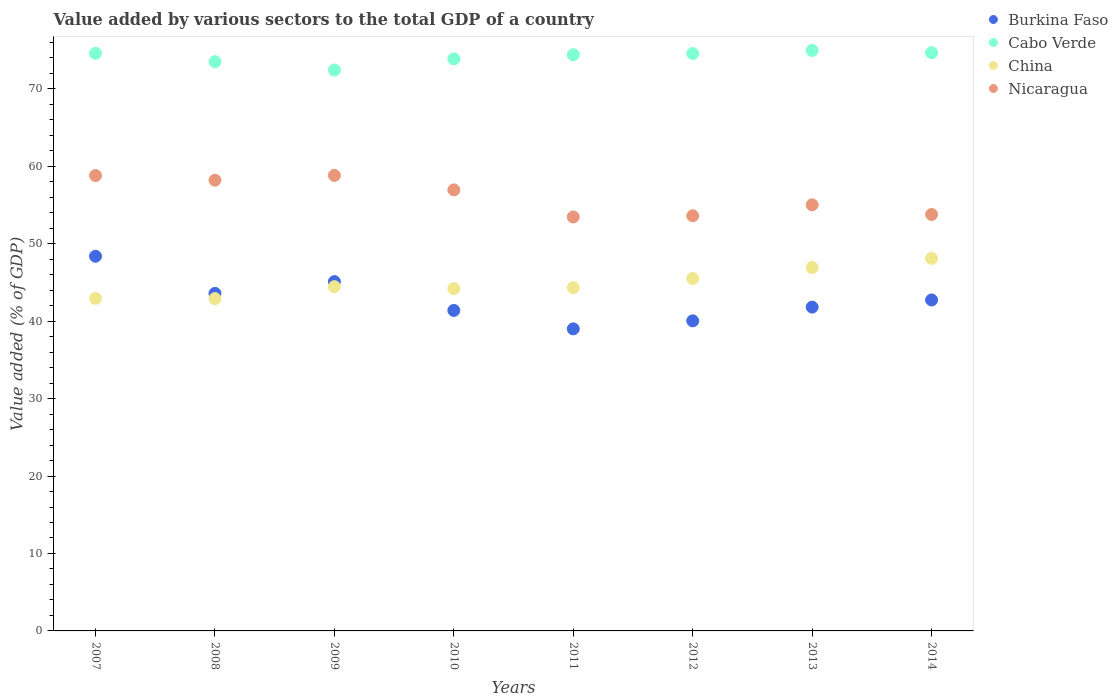What is the value added by various sectors to the total GDP in Cabo Verde in 2012?
Your answer should be very brief. 74.55. Across all years, what is the maximum value added by various sectors to the total GDP in Burkina Faso?
Offer a very short reply. 48.38. Across all years, what is the minimum value added by various sectors to the total GDP in Cabo Verde?
Ensure brevity in your answer.  72.42. In which year was the value added by various sectors to the total GDP in Burkina Faso minimum?
Provide a short and direct response. 2011. What is the total value added by various sectors to the total GDP in Burkina Faso in the graph?
Keep it short and to the point. 342.02. What is the difference between the value added by various sectors to the total GDP in Burkina Faso in 2012 and that in 2014?
Provide a succinct answer. -2.7. What is the difference between the value added by various sectors to the total GDP in Burkina Faso in 2011 and the value added by various sectors to the total GDP in China in 2013?
Offer a very short reply. -7.92. What is the average value added by various sectors to the total GDP in Burkina Faso per year?
Provide a succinct answer. 42.75. In the year 2014, what is the difference between the value added by various sectors to the total GDP in Cabo Verde and value added by various sectors to the total GDP in China?
Ensure brevity in your answer.  26.55. In how many years, is the value added by various sectors to the total GDP in Burkina Faso greater than 64 %?
Your response must be concise. 0. What is the ratio of the value added by various sectors to the total GDP in Cabo Verde in 2009 to that in 2011?
Ensure brevity in your answer.  0.97. Is the value added by various sectors to the total GDP in China in 2008 less than that in 2010?
Provide a short and direct response. Yes. Is the difference between the value added by various sectors to the total GDP in Cabo Verde in 2010 and 2011 greater than the difference between the value added by various sectors to the total GDP in China in 2010 and 2011?
Keep it short and to the point. No. What is the difference between the highest and the second highest value added by various sectors to the total GDP in Nicaragua?
Keep it short and to the point. 0.02. What is the difference between the highest and the lowest value added by various sectors to the total GDP in Nicaragua?
Offer a terse response. 5.37. In how many years, is the value added by various sectors to the total GDP in China greater than the average value added by various sectors to the total GDP in China taken over all years?
Make the answer very short. 3. Is it the case that in every year, the sum of the value added by various sectors to the total GDP in Nicaragua and value added by various sectors to the total GDP in Burkina Faso  is greater than the value added by various sectors to the total GDP in China?
Your response must be concise. Yes. Does the value added by various sectors to the total GDP in China monotonically increase over the years?
Give a very brief answer. No. Is the value added by various sectors to the total GDP in Burkina Faso strictly less than the value added by various sectors to the total GDP in China over the years?
Provide a succinct answer. No. How many dotlines are there?
Your response must be concise. 4. How many years are there in the graph?
Keep it short and to the point. 8. What is the difference between two consecutive major ticks on the Y-axis?
Provide a succinct answer. 10. Does the graph contain any zero values?
Your answer should be compact. No. Where does the legend appear in the graph?
Your answer should be very brief. Top right. How many legend labels are there?
Ensure brevity in your answer.  4. What is the title of the graph?
Give a very brief answer. Value added by various sectors to the total GDP of a country. What is the label or title of the Y-axis?
Give a very brief answer. Value added (% of GDP). What is the Value added (% of GDP) of Burkina Faso in 2007?
Keep it short and to the point. 48.38. What is the Value added (% of GDP) of Cabo Verde in 2007?
Your answer should be very brief. 74.58. What is the Value added (% of GDP) in China in 2007?
Make the answer very short. 42.94. What is the Value added (% of GDP) of Nicaragua in 2007?
Make the answer very short. 58.79. What is the Value added (% of GDP) of Burkina Faso in 2008?
Keep it short and to the point. 43.58. What is the Value added (% of GDP) in Cabo Verde in 2008?
Offer a terse response. 73.49. What is the Value added (% of GDP) of China in 2008?
Make the answer very short. 42.91. What is the Value added (% of GDP) in Nicaragua in 2008?
Provide a succinct answer. 58.2. What is the Value added (% of GDP) in Burkina Faso in 2009?
Ensure brevity in your answer.  45.1. What is the Value added (% of GDP) in Cabo Verde in 2009?
Make the answer very short. 72.42. What is the Value added (% of GDP) of China in 2009?
Ensure brevity in your answer.  44.45. What is the Value added (% of GDP) of Nicaragua in 2009?
Make the answer very short. 58.82. What is the Value added (% of GDP) in Burkina Faso in 2010?
Ensure brevity in your answer.  41.38. What is the Value added (% of GDP) in Cabo Verde in 2010?
Provide a succinct answer. 73.86. What is the Value added (% of GDP) of China in 2010?
Provide a short and direct response. 44.2. What is the Value added (% of GDP) in Nicaragua in 2010?
Make the answer very short. 56.95. What is the Value added (% of GDP) of Burkina Faso in 2011?
Provide a short and direct response. 39. What is the Value added (% of GDP) in Cabo Verde in 2011?
Provide a succinct answer. 74.39. What is the Value added (% of GDP) of China in 2011?
Keep it short and to the point. 44.32. What is the Value added (% of GDP) of Nicaragua in 2011?
Keep it short and to the point. 53.45. What is the Value added (% of GDP) of Burkina Faso in 2012?
Provide a short and direct response. 40.03. What is the Value added (% of GDP) in Cabo Verde in 2012?
Give a very brief answer. 74.55. What is the Value added (% of GDP) of China in 2012?
Keep it short and to the point. 45.5. What is the Value added (% of GDP) in Nicaragua in 2012?
Give a very brief answer. 53.6. What is the Value added (% of GDP) of Burkina Faso in 2013?
Ensure brevity in your answer.  41.81. What is the Value added (% of GDP) in Cabo Verde in 2013?
Provide a short and direct response. 74.94. What is the Value added (% of GDP) in China in 2013?
Keep it short and to the point. 46.92. What is the Value added (% of GDP) of Nicaragua in 2013?
Give a very brief answer. 55.01. What is the Value added (% of GDP) in Burkina Faso in 2014?
Ensure brevity in your answer.  42.74. What is the Value added (% of GDP) of Cabo Verde in 2014?
Your answer should be very brief. 74.66. What is the Value added (% of GDP) in China in 2014?
Your answer should be compact. 48.11. What is the Value added (% of GDP) in Nicaragua in 2014?
Offer a terse response. 53.77. Across all years, what is the maximum Value added (% of GDP) of Burkina Faso?
Your answer should be compact. 48.38. Across all years, what is the maximum Value added (% of GDP) of Cabo Verde?
Provide a succinct answer. 74.94. Across all years, what is the maximum Value added (% of GDP) in China?
Offer a terse response. 48.11. Across all years, what is the maximum Value added (% of GDP) in Nicaragua?
Give a very brief answer. 58.82. Across all years, what is the minimum Value added (% of GDP) of Burkina Faso?
Give a very brief answer. 39. Across all years, what is the minimum Value added (% of GDP) in Cabo Verde?
Your answer should be compact. 72.42. Across all years, what is the minimum Value added (% of GDP) of China?
Provide a short and direct response. 42.91. Across all years, what is the minimum Value added (% of GDP) of Nicaragua?
Your answer should be compact. 53.45. What is the total Value added (% of GDP) in Burkina Faso in the graph?
Offer a very short reply. 342.02. What is the total Value added (% of GDP) of Cabo Verde in the graph?
Your answer should be very brief. 592.89. What is the total Value added (% of GDP) of China in the graph?
Your answer should be compact. 359.35. What is the total Value added (% of GDP) of Nicaragua in the graph?
Your response must be concise. 448.59. What is the difference between the Value added (% of GDP) of Burkina Faso in 2007 and that in 2008?
Offer a very short reply. 4.8. What is the difference between the Value added (% of GDP) of Cabo Verde in 2007 and that in 2008?
Provide a short and direct response. 1.09. What is the difference between the Value added (% of GDP) of China in 2007 and that in 2008?
Make the answer very short. 0.03. What is the difference between the Value added (% of GDP) of Nicaragua in 2007 and that in 2008?
Offer a terse response. 0.6. What is the difference between the Value added (% of GDP) of Burkina Faso in 2007 and that in 2009?
Your answer should be very brief. 3.27. What is the difference between the Value added (% of GDP) of Cabo Verde in 2007 and that in 2009?
Your answer should be very brief. 2.16. What is the difference between the Value added (% of GDP) of China in 2007 and that in 2009?
Your answer should be very brief. -1.51. What is the difference between the Value added (% of GDP) in Nicaragua in 2007 and that in 2009?
Your answer should be compact. -0.02. What is the difference between the Value added (% of GDP) in Burkina Faso in 2007 and that in 2010?
Your answer should be very brief. 7. What is the difference between the Value added (% of GDP) of Cabo Verde in 2007 and that in 2010?
Keep it short and to the point. 0.72. What is the difference between the Value added (% of GDP) in China in 2007 and that in 2010?
Offer a terse response. -1.26. What is the difference between the Value added (% of GDP) in Nicaragua in 2007 and that in 2010?
Keep it short and to the point. 1.84. What is the difference between the Value added (% of GDP) of Burkina Faso in 2007 and that in 2011?
Ensure brevity in your answer.  9.37. What is the difference between the Value added (% of GDP) in Cabo Verde in 2007 and that in 2011?
Give a very brief answer. 0.19. What is the difference between the Value added (% of GDP) in China in 2007 and that in 2011?
Make the answer very short. -1.38. What is the difference between the Value added (% of GDP) of Nicaragua in 2007 and that in 2011?
Make the answer very short. 5.34. What is the difference between the Value added (% of GDP) of Burkina Faso in 2007 and that in 2012?
Ensure brevity in your answer.  8.34. What is the difference between the Value added (% of GDP) of Cabo Verde in 2007 and that in 2012?
Ensure brevity in your answer.  0.03. What is the difference between the Value added (% of GDP) of China in 2007 and that in 2012?
Provide a short and direct response. -2.56. What is the difference between the Value added (% of GDP) in Nicaragua in 2007 and that in 2012?
Provide a short and direct response. 5.19. What is the difference between the Value added (% of GDP) of Burkina Faso in 2007 and that in 2013?
Offer a terse response. 6.57. What is the difference between the Value added (% of GDP) of Cabo Verde in 2007 and that in 2013?
Ensure brevity in your answer.  -0.36. What is the difference between the Value added (% of GDP) in China in 2007 and that in 2013?
Give a very brief answer. -3.98. What is the difference between the Value added (% of GDP) of Nicaragua in 2007 and that in 2013?
Ensure brevity in your answer.  3.78. What is the difference between the Value added (% of GDP) of Burkina Faso in 2007 and that in 2014?
Give a very brief answer. 5.64. What is the difference between the Value added (% of GDP) of Cabo Verde in 2007 and that in 2014?
Keep it short and to the point. -0.08. What is the difference between the Value added (% of GDP) of China in 2007 and that in 2014?
Your answer should be compact. -5.17. What is the difference between the Value added (% of GDP) of Nicaragua in 2007 and that in 2014?
Offer a terse response. 5.02. What is the difference between the Value added (% of GDP) of Burkina Faso in 2008 and that in 2009?
Your answer should be compact. -1.52. What is the difference between the Value added (% of GDP) in Cabo Verde in 2008 and that in 2009?
Your answer should be compact. 1.07. What is the difference between the Value added (% of GDP) of China in 2008 and that in 2009?
Provide a succinct answer. -1.54. What is the difference between the Value added (% of GDP) in Nicaragua in 2008 and that in 2009?
Keep it short and to the point. -0.62. What is the difference between the Value added (% of GDP) in Burkina Faso in 2008 and that in 2010?
Keep it short and to the point. 2.2. What is the difference between the Value added (% of GDP) in Cabo Verde in 2008 and that in 2010?
Your response must be concise. -0.37. What is the difference between the Value added (% of GDP) in China in 2008 and that in 2010?
Ensure brevity in your answer.  -1.3. What is the difference between the Value added (% of GDP) in Nicaragua in 2008 and that in 2010?
Provide a short and direct response. 1.25. What is the difference between the Value added (% of GDP) of Burkina Faso in 2008 and that in 2011?
Offer a very short reply. 4.58. What is the difference between the Value added (% of GDP) of Cabo Verde in 2008 and that in 2011?
Give a very brief answer. -0.9. What is the difference between the Value added (% of GDP) in China in 2008 and that in 2011?
Your answer should be very brief. -1.42. What is the difference between the Value added (% of GDP) of Nicaragua in 2008 and that in 2011?
Offer a very short reply. 4.75. What is the difference between the Value added (% of GDP) of Burkina Faso in 2008 and that in 2012?
Ensure brevity in your answer.  3.54. What is the difference between the Value added (% of GDP) in Cabo Verde in 2008 and that in 2012?
Ensure brevity in your answer.  -1.06. What is the difference between the Value added (% of GDP) in China in 2008 and that in 2012?
Make the answer very short. -2.59. What is the difference between the Value added (% of GDP) of Nicaragua in 2008 and that in 2012?
Your response must be concise. 4.59. What is the difference between the Value added (% of GDP) in Burkina Faso in 2008 and that in 2013?
Your answer should be very brief. 1.77. What is the difference between the Value added (% of GDP) in Cabo Verde in 2008 and that in 2013?
Make the answer very short. -1.45. What is the difference between the Value added (% of GDP) in China in 2008 and that in 2013?
Your response must be concise. -4.01. What is the difference between the Value added (% of GDP) in Nicaragua in 2008 and that in 2013?
Offer a terse response. 3.19. What is the difference between the Value added (% of GDP) in Burkina Faso in 2008 and that in 2014?
Your answer should be very brief. 0.84. What is the difference between the Value added (% of GDP) of Cabo Verde in 2008 and that in 2014?
Provide a short and direct response. -1.17. What is the difference between the Value added (% of GDP) in China in 2008 and that in 2014?
Make the answer very short. -5.2. What is the difference between the Value added (% of GDP) of Nicaragua in 2008 and that in 2014?
Ensure brevity in your answer.  4.42. What is the difference between the Value added (% of GDP) in Burkina Faso in 2009 and that in 2010?
Offer a terse response. 3.72. What is the difference between the Value added (% of GDP) of Cabo Verde in 2009 and that in 2010?
Ensure brevity in your answer.  -1.44. What is the difference between the Value added (% of GDP) of China in 2009 and that in 2010?
Give a very brief answer. 0.25. What is the difference between the Value added (% of GDP) in Nicaragua in 2009 and that in 2010?
Keep it short and to the point. 1.87. What is the difference between the Value added (% of GDP) in Burkina Faso in 2009 and that in 2011?
Offer a very short reply. 6.1. What is the difference between the Value added (% of GDP) of Cabo Verde in 2009 and that in 2011?
Ensure brevity in your answer.  -1.97. What is the difference between the Value added (% of GDP) in China in 2009 and that in 2011?
Offer a terse response. 0.12. What is the difference between the Value added (% of GDP) in Nicaragua in 2009 and that in 2011?
Keep it short and to the point. 5.37. What is the difference between the Value added (% of GDP) in Burkina Faso in 2009 and that in 2012?
Give a very brief answer. 5.07. What is the difference between the Value added (% of GDP) in Cabo Verde in 2009 and that in 2012?
Your answer should be compact. -2.13. What is the difference between the Value added (% of GDP) in China in 2009 and that in 2012?
Ensure brevity in your answer.  -1.05. What is the difference between the Value added (% of GDP) of Nicaragua in 2009 and that in 2012?
Provide a succinct answer. 5.21. What is the difference between the Value added (% of GDP) of Burkina Faso in 2009 and that in 2013?
Ensure brevity in your answer.  3.29. What is the difference between the Value added (% of GDP) in Cabo Verde in 2009 and that in 2013?
Give a very brief answer. -2.52. What is the difference between the Value added (% of GDP) of China in 2009 and that in 2013?
Make the answer very short. -2.47. What is the difference between the Value added (% of GDP) in Nicaragua in 2009 and that in 2013?
Your answer should be very brief. 3.8. What is the difference between the Value added (% of GDP) of Burkina Faso in 2009 and that in 2014?
Your answer should be very brief. 2.37. What is the difference between the Value added (% of GDP) of Cabo Verde in 2009 and that in 2014?
Your answer should be very brief. -2.24. What is the difference between the Value added (% of GDP) of China in 2009 and that in 2014?
Your answer should be compact. -3.66. What is the difference between the Value added (% of GDP) in Nicaragua in 2009 and that in 2014?
Offer a terse response. 5.04. What is the difference between the Value added (% of GDP) in Burkina Faso in 2010 and that in 2011?
Provide a succinct answer. 2.38. What is the difference between the Value added (% of GDP) of Cabo Verde in 2010 and that in 2011?
Ensure brevity in your answer.  -0.53. What is the difference between the Value added (% of GDP) in China in 2010 and that in 2011?
Your answer should be very brief. -0.12. What is the difference between the Value added (% of GDP) in Nicaragua in 2010 and that in 2011?
Provide a succinct answer. 3.5. What is the difference between the Value added (% of GDP) of Burkina Faso in 2010 and that in 2012?
Offer a terse response. 1.35. What is the difference between the Value added (% of GDP) in Cabo Verde in 2010 and that in 2012?
Keep it short and to the point. -0.69. What is the difference between the Value added (% of GDP) in China in 2010 and that in 2012?
Give a very brief answer. -1.3. What is the difference between the Value added (% of GDP) of Nicaragua in 2010 and that in 2012?
Give a very brief answer. 3.34. What is the difference between the Value added (% of GDP) in Burkina Faso in 2010 and that in 2013?
Offer a terse response. -0.43. What is the difference between the Value added (% of GDP) of Cabo Verde in 2010 and that in 2013?
Ensure brevity in your answer.  -1.08. What is the difference between the Value added (% of GDP) in China in 2010 and that in 2013?
Ensure brevity in your answer.  -2.72. What is the difference between the Value added (% of GDP) in Nicaragua in 2010 and that in 2013?
Make the answer very short. 1.94. What is the difference between the Value added (% of GDP) of Burkina Faso in 2010 and that in 2014?
Your answer should be compact. -1.36. What is the difference between the Value added (% of GDP) in Cabo Verde in 2010 and that in 2014?
Give a very brief answer. -0.8. What is the difference between the Value added (% of GDP) of China in 2010 and that in 2014?
Give a very brief answer. -3.91. What is the difference between the Value added (% of GDP) of Nicaragua in 2010 and that in 2014?
Offer a terse response. 3.18. What is the difference between the Value added (% of GDP) in Burkina Faso in 2011 and that in 2012?
Provide a succinct answer. -1.03. What is the difference between the Value added (% of GDP) in Cabo Verde in 2011 and that in 2012?
Offer a very short reply. -0.16. What is the difference between the Value added (% of GDP) of China in 2011 and that in 2012?
Keep it short and to the point. -1.18. What is the difference between the Value added (% of GDP) in Nicaragua in 2011 and that in 2012?
Give a very brief answer. -0.16. What is the difference between the Value added (% of GDP) of Burkina Faso in 2011 and that in 2013?
Give a very brief answer. -2.81. What is the difference between the Value added (% of GDP) of Cabo Verde in 2011 and that in 2013?
Offer a terse response. -0.55. What is the difference between the Value added (% of GDP) in China in 2011 and that in 2013?
Keep it short and to the point. -2.59. What is the difference between the Value added (% of GDP) in Nicaragua in 2011 and that in 2013?
Make the answer very short. -1.56. What is the difference between the Value added (% of GDP) in Burkina Faso in 2011 and that in 2014?
Offer a very short reply. -3.73. What is the difference between the Value added (% of GDP) in Cabo Verde in 2011 and that in 2014?
Ensure brevity in your answer.  -0.26. What is the difference between the Value added (% of GDP) of China in 2011 and that in 2014?
Your response must be concise. -3.79. What is the difference between the Value added (% of GDP) in Nicaragua in 2011 and that in 2014?
Offer a terse response. -0.32. What is the difference between the Value added (% of GDP) in Burkina Faso in 2012 and that in 2013?
Offer a terse response. -1.78. What is the difference between the Value added (% of GDP) of Cabo Verde in 2012 and that in 2013?
Your answer should be very brief. -0.39. What is the difference between the Value added (% of GDP) in China in 2012 and that in 2013?
Provide a short and direct response. -1.42. What is the difference between the Value added (% of GDP) of Nicaragua in 2012 and that in 2013?
Provide a succinct answer. -1.41. What is the difference between the Value added (% of GDP) in Burkina Faso in 2012 and that in 2014?
Provide a succinct answer. -2.7. What is the difference between the Value added (% of GDP) in Cabo Verde in 2012 and that in 2014?
Your response must be concise. -0.11. What is the difference between the Value added (% of GDP) of China in 2012 and that in 2014?
Your response must be concise. -2.61. What is the difference between the Value added (% of GDP) of Nicaragua in 2012 and that in 2014?
Your response must be concise. -0.17. What is the difference between the Value added (% of GDP) in Burkina Faso in 2013 and that in 2014?
Your response must be concise. -0.93. What is the difference between the Value added (% of GDP) in Cabo Verde in 2013 and that in 2014?
Ensure brevity in your answer.  0.29. What is the difference between the Value added (% of GDP) of China in 2013 and that in 2014?
Give a very brief answer. -1.19. What is the difference between the Value added (% of GDP) in Nicaragua in 2013 and that in 2014?
Provide a succinct answer. 1.24. What is the difference between the Value added (% of GDP) of Burkina Faso in 2007 and the Value added (% of GDP) of Cabo Verde in 2008?
Keep it short and to the point. -25.11. What is the difference between the Value added (% of GDP) in Burkina Faso in 2007 and the Value added (% of GDP) in China in 2008?
Offer a terse response. 5.47. What is the difference between the Value added (% of GDP) in Burkina Faso in 2007 and the Value added (% of GDP) in Nicaragua in 2008?
Your answer should be compact. -9.82. What is the difference between the Value added (% of GDP) in Cabo Verde in 2007 and the Value added (% of GDP) in China in 2008?
Provide a succinct answer. 31.67. What is the difference between the Value added (% of GDP) in Cabo Verde in 2007 and the Value added (% of GDP) in Nicaragua in 2008?
Offer a very short reply. 16.38. What is the difference between the Value added (% of GDP) in China in 2007 and the Value added (% of GDP) in Nicaragua in 2008?
Provide a succinct answer. -15.26. What is the difference between the Value added (% of GDP) of Burkina Faso in 2007 and the Value added (% of GDP) of Cabo Verde in 2009?
Provide a succinct answer. -24.04. What is the difference between the Value added (% of GDP) in Burkina Faso in 2007 and the Value added (% of GDP) in China in 2009?
Make the answer very short. 3.93. What is the difference between the Value added (% of GDP) in Burkina Faso in 2007 and the Value added (% of GDP) in Nicaragua in 2009?
Keep it short and to the point. -10.44. What is the difference between the Value added (% of GDP) in Cabo Verde in 2007 and the Value added (% of GDP) in China in 2009?
Offer a very short reply. 30.13. What is the difference between the Value added (% of GDP) of Cabo Verde in 2007 and the Value added (% of GDP) of Nicaragua in 2009?
Provide a short and direct response. 15.76. What is the difference between the Value added (% of GDP) of China in 2007 and the Value added (% of GDP) of Nicaragua in 2009?
Provide a short and direct response. -15.87. What is the difference between the Value added (% of GDP) of Burkina Faso in 2007 and the Value added (% of GDP) of Cabo Verde in 2010?
Provide a short and direct response. -25.49. What is the difference between the Value added (% of GDP) of Burkina Faso in 2007 and the Value added (% of GDP) of China in 2010?
Your answer should be very brief. 4.17. What is the difference between the Value added (% of GDP) in Burkina Faso in 2007 and the Value added (% of GDP) in Nicaragua in 2010?
Make the answer very short. -8.57. What is the difference between the Value added (% of GDP) of Cabo Verde in 2007 and the Value added (% of GDP) of China in 2010?
Ensure brevity in your answer.  30.38. What is the difference between the Value added (% of GDP) in Cabo Verde in 2007 and the Value added (% of GDP) in Nicaragua in 2010?
Ensure brevity in your answer.  17.63. What is the difference between the Value added (% of GDP) in China in 2007 and the Value added (% of GDP) in Nicaragua in 2010?
Provide a short and direct response. -14.01. What is the difference between the Value added (% of GDP) of Burkina Faso in 2007 and the Value added (% of GDP) of Cabo Verde in 2011?
Offer a very short reply. -26.02. What is the difference between the Value added (% of GDP) of Burkina Faso in 2007 and the Value added (% of GDP) of China in 2011?
Provide a succinct answer. 4.05. What is the difference between the Value added (% of GDP) in Burkina Faso in 2007 and the Value added (% of GDP) in Nicaragua in 2011?
Your response must be concise. -5.07. What is the difference between the Value added (% of GDP) in Cabo Verde in 2007 and the Value added (% of GDP) in China in 2011?
Your answer should be very brief. 30.25. What is the difference between the Value added (% of GDP) of Cabo Verde in 2007 and the Value added (% of GDP) of Nicaragua in 2011?
Ensure brevity in your answer.  21.13. What is the difference between the Value added (% of GDP) of China in 2007 and the Value added (% of GDP) of Nicaragua in 2011?
Offer a very short reply. -10.51. What is the difference between the Value added (% of GDP) of Burkina Faso in 2007 and the Value added (% of GDP) of Cabo Verde in 2012?
Provide a succinct answer. -26.17. What is the difference between the Value added (% of GDP) in Burkina Faso in 2007 and the Value added (% of GDP) in China in 2012?
Ensure brevity in your answer.  2.88. What is the difference between the Value added (% of GDP) of Burkina Faso in 2007 and the Value added (% of GDP) of Nicaragua in 2012?
Make the answer very short. -5.23. What is the difference between the Value added (% of GDP) in Cabo Verde in 2007 and the Value added (% of GDP) in China in 2012?
Offer a terse response. 29.08. What is the difference between the Value added (% of GDP) in Cabo Verde in 2007 and the Value added (% of GDP) in Nicaragua in 2012?
Your answer should be very brief. 20.97. What is the difference between the Value added (% of GDP) of China in 2007 and the Value added (% of GDP) of Nicaragua in 2012?
Provide a succinct answer. -10.66. What is the difference between the Value added (% of GDP) in Burkina Faso in 2007 and the Value added (% of GDP) in Cabo Verde in 2013?
Provide a short and direct response. -26.57. What is the difference between the Value added (% of GDP) of Burkina Faso in 2007 and the Value added (% of GDP) of China in 2013?
Your answer should be compact. 1.46. What is the difference between the Value added (% of GDP) in Burkina Faso in 2007 and the Value added (% of GDP) in Nicaragua in 2013?
Your answer should be compact. -6.64. What is the difference between the Value added (% of GDP) in Cabo Verde in 2007 and the Value added (% of GDP) in China in 2013?
Make the answer very short. 27.66. What is the difference between the Value added (% of GDP) in Cabo Verde in 2007 and the Value added (% of GDP) in Nicaragua in 2013?
Offer a very short reply. 19.57. What is the difference between the Value added (% of GDP) of China in 2007 and the Value added (% of GDP) of Nicaragua in 2013?
Your response must be concise. -12.07. What is the difference between the Value added (% of GDP) of Burkina Faso in 2007 and the Value added (% of GDP) of Cabo Verde in 2014?
Offer a very short reply. -26.28. What is the difference between the Value added (% of GDP) of Burkina Faso in 2007 and the Value added (% of GDP) of China in 2014?
Offer a very short reply. 0.27. What is the difference between the Value added (% of GDP) in Burkina Faso in 2007 and the Value added (% of GDP) in Nicaragua in 2014?
Your response must be concise. -5.4. What is the difference between the Value added (% of GDP) in Cabo Verde in 2007 and the Value added (% of GDP) in China in 2014?
Keep it short and to the point. 26.47. What is the difference between the Value added (% of GDP) of Cabo Verde in 2007 and the Value added (% of GDP) of Nicaragua in 2014?
Make the answer very short. 20.81. What is the difference between the Value added (% of GDP) of China in 2007 and the Value added (% of GDP) of Nicaragua in 2014?
Your answer should be very brief. -10.83. What is the difference between the Value added (% of GDP) of Burkina Faso in 2008 and the Value added (% of GDP) of Cabo Verde in 2009?
Provide a short and direct response. -28.84. What is the difference between the Value added (% of GDP) in Burkina Faso in 2008 and the Value added (% of GDP) in China in 2009?
Keep it short and to the point. -0.87. What is the difference between the Value added (% of GDP) in Burkina Faso in 2008 and the Value added (% of GDP) in Nicaragua in 2009?
Your answer should be compact. -15.24. What is the difference between the Value added (% of GDP) in Cabo Verde in 2008 and the Value added (% of GDP) in China in 2009?
Offer a very short reply. 29.04. What is the difference between the Value added (% of GDP) of Cabo Verde in 2008 and the Value added (% of GDP) of Nicaragua in 2009?
Keep it short and to the point. 14.67. What is the difference between the Value added (% of GDP) in China in 2008 and the Value added (% of GDP) in Nicaragua in 2009?
Keep it short and to the point. -15.91. What is the difference between the Value added (% of GDP) of Burkina Faso in 2008 and the Value added (% of GDP) of Cabo Verde in 2010?
Provide a short and direct response. -30.28. What is the difference between the Value added (% of GDP) in Burkina Faso in 2008 and the Value added (% of GDP) in China in 2010?
Give a very brief answer. -0.62. What is the difference between the Value added (% of GDP) of Burkina Faso in 2008 and the Value added (% of GDP) of Nicaragua in 2010?
Keep it short and to the point. -13.37. What is the difference between the Value added (% of GDP) in Cabo Verde in 2008 and the Value added (% of GDP) in China in 2010?
Ensure brevity in your answer.  29.29. What is the difference between the Value added (% of GDP) in Cabo Verde in 2008 and the Value added (% of GDP) in Nicaragua in 2010?
Make the answer very short. 16.54. What is the difference between the Value added (% of GDP) of China in 2008 and the Value added (% of GDP) of Nicaragua in 2010?
Your response must be concise. -14.04. What is the difference between the Value added (% of GDP) of Burkina Faso in 2008 and the Value added (% of GDP) of Cabo Verde in 2011?
Keep it short and to the point. -30.81. What is the difference between the Value added (% of GDP) of Burkina Faso in 2008 and the Value added (% of GDP) of China in 2011?
Give a very brief answer. -0.75. What is the difference between the Value added (% of GDP) in Burkina Faso in 2008 and the Value added (% of GDP) in Nicaragua in 2011?
Your answer should be compact. -9.87. What is the difference between the Value added (% of GDP) of Cabo Verde in 2008 and the Value added (% of GDP) of China in 2011?
Provide a succinct answer. 29.17. What is the difference between the Value added (% of GDP) of Cabo Verde in 2008 and the Value added (% of GDP) of Nicaragua in 2011?
Make the answer very short. 20.04. What is the difference between the Value added (% of GDP) in China in 2008 and the Value added (% of GDP) in Nicaragua in 2011?
Ensure brevity in your answer.  -10.54. What is the difference between the Value added (% of GDP) in Burkina Faso in 2008 and the Value added (% of GDP) in Cabo Verde in 2012?
Make the answer very short. -30.97. What is the difference between the Value added (% of GDP) in Burkina Faso in 2008 and the Value added (% of GDP) in China in 2012?
Your answer should be compact. -1.92. What is the difference between the Value added (% of GDP) of Burkina Faso in 2008 and the Value added (% of GDP) of Nicaragua in 2012?
Your answer should be very brief. -10.03. What is the difference between the Value added (% of GDP) of Cabo Verde in 2008 and the Value added (% of GDP) of China in 2012?
Ensure brevity in your answer.  27.99. What is the difference between the Value added (% of GDP) in Cabo Verde in 2008 and the Value added (% of GDP) in Nicaragua in 2012?
Offer a very short reply. 19.89. What is the difference between the Value added (% of GDP) of China in 2008 and the Value added (% of GDP) of Nicaragua in 2012?
Your answer should be very brief. -10.7. What is the difference between the Value added (% of GDP) in Burkina Faso in 2008 and the Value added (% of GDP) in Cabo Verde in 2013?
Keep it short and to the point. -31.36. What is the difference between the Value added (% of GDP) in Burkina Faso in 2008 and the Value added (% of GDP) in China in 2013?
Your response must be concise. -3.34. What is the difference between the Value added (% of GDP) of Burkina Faso in 2008 and the Value added (% of GDP) of Nicaragua in 2013?
Make the answer very short. -11.43. What is the difference between the Value added (% of GDP) of Cabo Verde in 2008 and the Value added (% of GDP) of China in 2013?
Keep it short and to the point. 26.57. What is the difference between the Value added (% of GDP) in Cabo Verde in 2008 and the Value added (% of GDP) in Nicaragua in 2013?
Offer a terse response. 18.48. What is the difference between the Value added (% of GDP) of China in 2008 and the Value added (% of GDP) of Nicaragua in 2013?
Your answer should be very brief. -12.1. What is the difference between the Value added (% of GDP) in Burkina Faso in 2008 and the Value added (% of GDP) in Cabo Verde in 2014?
Give a very brief answer. -31.08. What is the difference between the Value added (% of GDP) of Burkina Faso in 2008 and the Value added (% of GDP) of China in 2014?
Offer a terse response. -4.53. What is the difference between the Value added (% of GDP) of Burkina Faso in 2008 and the Value added (% of GDP) of Nicaragua in 2014?
Give a very brief answer. -10.19. What is the difference between the Value added (% of GDP) of Cabo Verde in 2008 and the Value added (% of GDP) of China in 2014?
Offer a terse response. 25.38. What is the difference between the Value added (% of GDP) of Cabo Verde in 2008 and the Value added (% of GDP) of Nicaragua in 2014?
Your answer should be compact. 19.72. What is the difference between the Value added (% of GDP) in China in 2008 and the Value added (% of GDP) in Nicaragua in 2014?
Keep it short and to the point. -10.87. What is the difference between the Value added (% of GDP) in Burkina Faso in 2009 and the Value added (% of GDP) in Cabo Verde in 2010?
Provide a succinct answer. -28.76. What is the difference between the Value added (% of GDP) of Burkina Faso in 2009 and the Value added (% of GDP) of China in 2010?
Your answer should be very brief. 0.9. What is the difference between the Value added (% of GDP) of Burkina Faso in 2009 and the Value added (% of GDP) of Nicaragua in 2010?
Offer a very short reply. -11.85. What is the difference between the Value added (% of GDP) in Cabo Verde in 2009 and the Value added (% of GDP) in China in 2010?
Give a very brief answer. 28.22. What is the difference between the Value added (% of GDP) of Cabo Verde in 2009 and the Value added (% of GDP) of Nicaragua in 2010?
Make the answer very short. 15.47. What is the difference between the Value added (% of GDP) of China in 2009 and the Value added (% of GDP) of Nicaragua in 2010?
Your answer should be compact. -12.5. What is the difference between the Value added (% of GDP) in Burkina Faso in 2009 and the Value added (% of GDP) in Cabo Verde in 2011?
Make the answer very short. -29.29. What is the difference between the Value added (% of GDP) in Burkina Faso in 2009 and the Value added (% of GDP) in China in 2011?
Provide a short and direct response. 0.78. What is the difference between the Value added (% of GDP) in Burkina Faso in 2009 and the Value added (% of GDP) in Nicaragua in 2011?
Your response must be concise. -8.35. What is the difference between the Value added (% of GDP) in Cabo Verde in 2009 and the Value added (% of GDP) in China in 2011?
Your response must be concise. 28.1. What is the difference between the Value added (% of GDP) of Cabo Verde in 2009 and the Value added (% of GDP) of Nicaragua in 2011?
Your answer should be very brief. 18.97. What is the difference between the Value added (% of GDP) of China in 2009 and the Value added (% of GDP) of Nicaragua in 2011?
Offer a terse response. -9. What is the difference between the Value added (% of GDP) in Burkina Faso in 2009 and the Value added (% of GDP) in Cabo Verde in 2012?
Provide a succinct answer. -29.45. What is the difference between the Value added (% of GDP) of Burkina Faso in 2009 and the Value added (% of GDP) of China in 2012?
Provide a succinct answer. -0.4. What is the difference between the Value added (% of GDP) of Burkina Faso in 2009 and the Value added (% of GDP) of Nicaragua in 2012?
Give a very brief answer. -8.5. What is the difference between the Value added (% of GDP) in Cabo Verde in 2009 and the Value added (% of GDP) in China in 2012?
Offer a terse response. 26.92. What is the difference between the Value added (% of GDP) in Cabo Verde in 2009 and the Value added (% of GDP) in Nicaragua in 2012?
Your answer should be compact. 18.82. What is the difference between the Value added (% of GDP) in China in 2009 and the Value added (% of GDP) in Nicaragua in 2012?
Ensure brevity in your answer.  -9.16. What is the difference between the Value added (% of GDP) of Burkina Faso in 2009 and the Value added (% of GDP) of Cabo Verde in 2013?
Make the answer very short. -29.84. What is the difference between the Value added (% of GDP) in Burkina Faso in 2009 and the Value added (% of GDP) in China in 2013?
Provide a succinct answer. -1.82. What is the difference between the Value added (% of GDP) in Burkina Faso in 2009 and the Value added (% of GDP) in Nicaragua in 2013?
Keep it short and to the point. -9.91. What is the difference between the Value added (% of GDP) of Cabo Verde in 2009 and the Value added (% of GDP) of China in 2013?
Ensure brevity in your answer.  25.5. What is the difference between the Value added (% of GDP) in Cabo Verde in 2009 and the Value added (% of GDP) in Nicaragua in 2013?
Offer a very short reply. 17.41. What is the difference between the Value added (% of GDP) of China in 2009 and the Value added (% of GDP) of Nicaragua in 2013?
Your answer should be very brief. -10.56. What is the difference between the Value added (% of GDP) in Burkina Faso in 2009 and the Value added (% of GDP) in Cabo Verde in 2014?
Give a very brief answer. -29.56. What is the difference between the Value added (% of GDP) in Burkina Faso in 2009 and the Value added (% of GDP) in China in 2014?
Offer a terse response. -3.01. What is the difference between the Value added (% of GDP) in Burkina Faso in 2009 and the Value added (% of GDP) in Nicaragua in 2014?
Make the answer very short. -8.67. What is the difference between the Value added (% of GDP) in Cabo Verde in 2009 and the Value added (% of GDP) in China in 2014?
Offer a very short reply. 24.31. What is the difference between the Value added (% of GDP) of Cabo Verde in 2009 and the Value added (% of GDP) of Nicaragua in 2014?
Ensure brevity in your answer.  18.65. What is the difference between the Value added (% of GDP) of China in 2009 and the Value added (% of GDP) of Nicaragua in 2014?
Make the answer very short. -9.32. What is the difference between the Value added (% of GDP) in Burkina Faso in 2010 and the Value added (% of GDP) in Cabo Verde in 2011?
Offer a terse response. -33.01. What is the difference between the Value added (% of GDP) in Burkina Faso in 2010 and the Value added (% of GDP) in China in 2011?
Offer a terse response. -2.94. What is the difference between the Value added (% of GDP) in Burkina Faso in 2010 and the Value added (% of GDP) in Nicaragua in 2011?
Offer a terse response. -12.07. What is the difference between the Value added (% of GDP) in Cabo Verde in 2010 and the Value added (% of GDP) in China in 2011?
Give a very brief answer. 29.54. What is the difference between the Value added (% of GDP) in Cabo Verde in 2010 and the Value added (% of GDP) in Nicaragua in 2011?
Provide a short and direct response. 20.41. What is the difference between the Value added (% of GDP) of China in 2010 and the Value added (% of GDP) of Nicaragua in 2011?
Make the answer very short. -9.25. What is the difference between the Value added (% of GDP) of Burkina Faso in 2010 and the Value added (% of GDP) of Cabo Verde in 2012?
Your answer should be compact. -33.17. What is the difference between the Value added (% of GDP) of Burkina Faso in 2010 and the Value added (% of GDP) of China in 2012?
Your answer should be compact. -4.12. What is the difference between the Value added (% of GDP) of Burkina Faso in 2010 and the Value added (% of GDP) of Nicaragua in 2012?
Provide a short and direct response. -12.22. What is the difference between the Value added (% of GDP) in Cabo Verde in 2010 and the Value added (% of GDP) in China in 2012?
Provide a short and direct response. 28.36. What is the difference between the Value added (% of GDP) in Cabo Verde in 2010 and the Value added (% of GDP) in Nicaragua in 2012?
Your response must be concise. 20.26. What is the difference between the Value added (% of GDP) in China in 2010 and the Value added (% of GDP) in Nicaragua in 2012?
Give a very brief answer. -9.4. What is the difference between the Value added (% of GDP) of Burkina Faso in 2010 and the Value added (% of GDP) of Cabo Verde in 2013?
Your answer should be compact. -33.56. What is the difference between the Value added (% of GDP) in Burkina Faso in 2010 and the Value added (% of GDP) in China in 2013?
Your response must be concise. -5.54. What is the difference between the Value added (% of GDP) of Burkina Faso in 2010 and the Value added (% of GDP) of Nicaragua in 2013?
Your response must be concise. -13.63. What is the difference between the Value added (% of GDP) of Cabo Verde in 2010 and the Value added (% of GDP) of China in 2013?
Provide a short and direct response. 26.94. What is the difference between the Value added (% of GDP) in Cabo Verde in 2010 and the Value added (% of GDP) in Nicaragua in 2013?
Make the answer very short. 18.85. What is the difference between the Value added (% of GDP) of China in 2010 and the Value added (% of GDP) of Nicaragua in 2013?
Your response must be concise. -10.81. What is the difference between the Value added (% of GDP) in Burkina Faso in 2010 and the Value added (% of GDP) in Cabo Verde in 2014?
Give a very brief answer. -33.28. What is the difference between the Value added (% of GDP) of Burkina Faso in 2010 and the Value added (% of GDP) of China in 2014?
Provide a short and direct response. -6.73. What is the difference between the Value added (% of GDP) in Burkina Faso in 2010 and the Value added (% of GDP) in Nicaragua in 2014?
Your response must be concise. -12.39. What is the difference between the Value added (% of GDP) of Cabo Verde in 2010 and the Value added (% of GDP) of China in 2014?
Keep it short and to the point. 25.75. What is the difference between the Value added (% of GDP) of Cabo Verde in 2010 and the Value added (% of GDP) of Nicaragua in 2014?
Provide a succinct answer. 20.09. What is the difference between the Value added (% of GDP) in China in 2010 and the Value added (% of GDP) in Nicaragua in 2014?
Give a very brief answer. -9.57. What is the difference between the Value added (% of GDP) in Burkina Faso in 2011 and the Value added (% of GDP) in Cabo Verde in 2012?
Your answer should be compact. -35.55. What is the difference between the Value added (% of GDP) in Burkina Faso in 2011 and the Value added (% of GDP) in China in 2012?
Give a very brief answer. -6.5. What is the difference between the Value added (% of GDP) of Burkina Faso in 2011 and the Value added (% of GDP) of Nicaragua in 2012?
Ensure brevity in your answer.  -14.6. What is the difference between the Value added (% of GDP) of Cabo Verde in 2011 and the Value added (% of GDP) of China in 2012?
Keep it short and to the point. 28.89. What is the difference between the Value added (% of GDP) of Cabo Verde in 2011 and the Value added (% of GDP) of Nicaragua in 2012?
Make the answer very short. 20.79. What is the difference between the Value added (% of GDP) in China in 2011 and the Value added (% of GDP) in Nicaragua in 2012?
Your answer should be compact. -9.28. What is the difference between the Value added (% of GDP) of Burkina Faso in 2011 and the Value added (% of GDP) of Cabo Verde in 2013?
Keep it short and to the point. -35.94. What is the difference between the Value added (% of GDP) in Burkina Faso in 2011 and the Value added (% of GDP) in China in 2013?
Provide a short and direct response. -7.92. What is the difference between the Value added (% of GDP) of Burkina Faso in 2011 and the Value added (% of GDP) of Nicaragua in 2013?
Provide a short and direct response. -16.01. What is the difference between the Value added (% of GDP) of Cabo Verde in 2011 and the Value added (% of GDP) of China in 2013?
Make the answer very short. 27.47. What is the difference between the Value added (% of GDP) of Cabo Verde in 2011 and the Value added (% of GDP) of Nicaragua in 2013?
Offer a terse response. 19.38. What is the difference between the Value added (% of GDP) of China in 2011 and the Value added (% of GDP) of Nicaragua in 2013?
Make the answer very short. -10.69. What is the difference between the Value added (% of GDP) in Burkina Faso in 2011 and the Value added (% of GDP) in Cabo Verde in 2014?
Your response must be concise. -35.66. What is the difference between the Value added (% of GDP) in Burkina Faso in 2011 and the Value added (% of GDP) in China in 2014?
Your answer should be compact. -9.11. What is the difference between the Value added (% of GDP) in Burkina Faso in 2011 and the Value added (% of GDP) in Nicaragua in 2014?
Make the answer very short. -14.77. What is the difference between the Value added (% of GDP) in Cabo Verde in 2011 and the Value added (% of GDP) in China in 2014?
Your response must be concise. 26.28. What is the difference between the Value added (% of GDP) of Cabo Verde in 2011 and the Value added (% of GDP) of Nicaragua in 2014?
Make the answer very short. 20.62. What is the difference between the Value added (% of GDP) in China in 2011 and the Value added (% of GDP) in Nicaragua in 2014?
Make the answer very short. -9.45. What is the difference between the Value added (% of GDP) of Burkina Faso in 2012 and the Value added (% of GDP) of Cabo Verde in 2013?
Your answer should be very brief. -34.91. What is the difference between the Value added (% of GDP) of Burkina Faso in 2012 and the Value added (% of GDP) of China in 2013?
Your answer should be compact. -6.89. What is the difference between the Value added (% of GDP) in Burkina Faso in 2012 and the Value added (% of GDP) in Nicaragua in 2013?
Provide a short and direct response. -14.98. What is the difference between the Value added (% of GDP) of Cabo Verde in 2012 and the Value added (% of GDP) of China in 2013?
Make the answer very short. 27.63. What is the difference between the Value added (% of GDP) of Cabo Verde in 2012 and the Value added (% of GDP) of Nicaragua in 2013?
Keep it short and to the point. 19.54. What is the difference between the Value added (% of GDP) of China in 2012 and the Value added (% of GDP) of Nicaragua in 2013?
Keep it short and to the point. -9.51. What is the difference between the Value added (% of GDP) in Burkina Faso in 2012 and the Value added (% of GDP) in Cabo Verde in 2014?
Provide a short and direct response. -34.62. What is the difference between the Value added (% of GDP) in Burkina Faso in 2012 and the Value added (% of GDP) in China in 2014?
Your answer should be compact. -8.08. What is the difference between the Value added (% of GDP) in Burkina Faso in 2012 and the Value added (% of GDP) in Nicaragua in 2014?
Your answer should be compact. -13.74. What is the difference between the Value added (% of GDP) in Cabo Verde in 2012 and the Value added (% of GDP) in China in 2014?
Your answer should be very brief. 26.44. What is the difference between the Value added (% of GDP) of Cabo Verde in 2012 and the Value added (% of GDP) of Nicaragua in 2014?
Provide a short and direct response. 20.78. What is the difference between the Value added (% of GDP) in China in 2012 and the Value added (% of GDP) in Nicaragua in 2014?
Ensure brevity in your answer.  -8.27. What is the difference between the Value added (% of GDP) of Burkina Faso in 2013 and the Value added (% of GDP) of Cabo Verde in 2014?
Your answer should be very brief. -32.85. What is the difference between the Value added (% of GDP) in Burkina Faso in 2013 and the Value added (% of GDP) in China in 2014?
Provide a short and direct response. -6.3. What is the difference between the Value added (% of GDP) in Burkina Faso in 2013 and the Value added (% of GDP) in Nicaragua in 2014?
Provide a succinct answer. -11.96. What is the difference between the Value added (% of GDP) in Cabo Verde in 2013 and the Value added (% of GDP) in China in 2014?
Ensure brevity in your answer.  26.83. What is the difference between the Value added (% of GDP) of Cabo Verde in 2013 and the Value added (% of GDP) of Nicaragua in 2014?
Your answer should be very brief. 21.17. What is the difference between the Value added (% of GDP) in China in 2013 and the Value added (% of GDP) in Nicaragua in 2014?
Provide a succinct answer. -6.85. What is the average Value added (% of GDP) in Burkina Faso per year?
Give a very brief answer. 42.75. What is the average Value added (% of GDP) in Cabo Verde per year?
Make the answer very short. 74.11. What is the average Value added (% of GDP) in China per year?
Offer a terse response. 44.92. What is the average Value added (% of GDP) of Nicaragua per year?
Ensure brevity in your answer.  56.07. In the year 2007, what is the difference between the Value added (% of GDP) in Burkina Faso and Value added (% of GDP) in Cabo Verde?
Offer a terse response. -26.2. In the year 2007, what is the difference between the Value added (% of GDP) of Burkina Faso and Value added (% of GDP) of China?
Give a very brief answer. 5.43. In the year 2007, what is the difference between the Value added (% of GDP) in Burkina Faso and Value added (% of GDP) in Nicaragua?
Your answer should be compact. -10.42. In the year 2007, what is the difference between the Value added (% of GDP) of Cabo Verde and Value added (% of GDP) of China?
Offer a very short reply. 31.64. In the year 2007, what is the difference between the Value added (% of GDP) in Cabo Verde and Value added (% of GDP) in Nicaragua?
Make the answer very short. 15.79. In the year 2007, what is the difference between the Value added (% of GDP) of China and Value added (% of GDP) of Nicaragua?
Your response must be concise. -15.85. In the year 2008, what is the difference between the Value added (% of GDP) of Burkina Faso and Value added (% of GDP) of Cabo Verde?
Provide a succinct answer. -29.91. In the year 2008, what is the difference between the Value added (% of GDP) in Burkina Faso and Value added (% of GDP) in China?
Provide a succinct answer. 0.67. In the year 2008, what is the difference between the Value added (% of GDP) of Burkina Faso and Value added (% of GDP) of Nicaragua?
Your answer should be compact. -14.62. In the year 2008, what is the difference between the Value added (% of GDP) of Cabo Verde and Value added (% of GDP) of China?
Keep it short and to the point. 30.58. In the year 2008, what is the difference between the Value added (% of GDP) in Cabo Verde and Value added (% of GDP) in Nicaragua?
Ensure brevity in your answer.  15.29. In the year 2008, what is the difference between the Value added (% of GDP) in China and Value added (% of GDP) in Nicaragua?
Your answer should be compact. -15.29. In the year 2009, what is the difference between the Value added (% of GDP) in Burkina Faso and Value added (% of GDP) in Cabo Verde?
Offer a very short reply. -27.32. In the year 2009, what is the difference between the Value added (% of GDP) of Burkina Faso and Value added (% of GDP) of China?
Ensure brevity in your answer.  0.65. In the year 2009, what is the difference between the Value added (% of GDP) of Burkina Faso and Value added (% of GDP) of Nicaragua?
Make the answer very short. -13.71. In the year 2009, what is the difference between the Value added (% of GDP) of Cabo Verde and Value added (% of GDP) of China?
Provide a short and direct response. 27.97. In the year 2009, what is the difference between the Value added (% of GDP) of Cabo Verde and Value added (% of GDP) of Nicaragua?
Make the answer very short. 13.6. In the year 2009, what is the difference between the Value added (% of GDP) in China and Value added (% of GDP) in Nicaragua?
Make the answer very short. -14.37. In the year 2010, what is the difference between the Value added (% of GDP) in Burkina Faso and Value added (% of GDP) in Cabo Verde?
Your answer should be very brief. -32.48. In the year 2010, what is the difference between the Value added (% of GDP) of Burkina Faso and Value added (% of GDP) of China?
Ensure brevity in your answer.  -2.82. In the year 2010, what is the difference between the Value added (% of GDP) of Burkina Faso and Value added (% of GDP) of Nicaragua?
Your response must be concise. -15.57. In the year 2010, what is the difference between the Value added (% of GDP) in Cabo Verde and Value added (% of GDP) in China?
Make the answer very short. 29.66. In the year 2010, what is the difference between the Value added (% of GDP) of Cabo Verde and Value added (% of GDP) of Nicaragua?
Your answer should be very brief. 16.91. In the year 2010, what is the difference between the Value added (% of GDP) of China and Value added (% of GDP) of Nicaragua?
Offer a terse response. -12.75. In the year 2011, what is the difference between the Value added (% of GDP) of Burkina Faso and Value added (% of GDP) of Cabo Verde?
Offer a terse response. -35.39. In the year 2011, what is the difference between the Value added (% of GDP) in Burkina Faso and Value added (% of GDP) in China?
Your answer should be very brief. -5.32. In the year 2011, what is the difference between the Value added (% of GDP) of Burkina Faso and Value added (% of GDP) of Nicaragua?
Offer a very short reply. -14.45. In the year 2011, what is the difference between the Value added (% of GDP) in Cabo Verde and Value added (% of GDP) in China?
Ensure brevity in your answer.  30.07. In the year 2011, what is the difference between the Value added (% of GDP) of Cabo Verde and Value added (% of GDP) of Nicaragua?
Ensure brevity in your answer.  20.94. In the year 2011, what is the difference between the Value added (% of GDP) in China and Value added (% of GDP) in Nicaragua?
Offer a terse response. -9.12. In the year 2012, what is the difference between the Value added (% of GDP) in Burkina Faso and Value added (% of GDP) in Cabo Verde?
Your response must be concise. -34.52. In the year 2012, what is the difference between the Value added (% of GDP) of Burkina Faso and Value added (% of GDP) of China?
Give a very brief answer. -5.47. In the year 2012, what is the difference between the Value added (% of GDP) in Burkina Faso and Value added (% of GDP) in Nicaragua?
Make the answer very short. -13.57. In the year 2012, what is the difference between the Value added (% of GDP) in Cabo Verde and Value added (% of GDP) in China?
Offer a very short reply. 29.05. In the year 2012, what is the difference between the Value added (% of GDP) of Cabo Verde and Value added (% of GDP) of Nicaragua?
Your answer should be very brief. 20.94. In the year 2012, what is the difference between the Value added (% of GDP) of China and Value added (% of GDP) of Nicaragua?
Give a very brief answer. -8.1. In the year 2013, what is the difference between the Value added (% of GDP) of Burkina Faso and Value added (% of GDP) of Cabo Verde?
Your answer should be compact. -33.13. In the year 2013, what is the difference between the Value added (% of GDP) of Burkina Faso and Value added (% of GDP) of China?
Your answer should be very brief. -5.11. In the year 2013, what is the difference between the Value added (% of GDP) in Burkina Faso and Value added (% of GDP) in Nicaragua?
Ensure brevity in your answer.  -13.2. In the year 2013, what is the difference between the Value added (% of GDP) in Cabo Verde and Value added (% of GDP) in China?
Keep it short and to the point. 28.02. In the year 2013, what is the difference between the Value added (% of GDP) in Cabo Verde and Value added (% of GDP) in Nicaragua?
Offer a terse response. 19.93. In the year 2013, what is the difference between the Value added (% of GDP) of China and Value added (% of GDP) of Nicaragua?
Provide a succinct answer. -8.09. In the year 2014, what is the difference between the Value added (% of GDP) in Burkina Faso and Value added (% of GDP) in Cabo Verde?
Ensure brevity in your answer.  -31.92. In the year 2014, what is the difference between the Value added (% of GDP) in Burkina Faso and Value added (% of GDP) in China?
Provide a short and direct response. -5.37. In the year 2014, what is the difference between the Value added (% of GDP) in Burkina Faso and Value added (% of GDP) in Nicaragua?
Offer a terse response. -11.04. In the year 2014, what is the difference between the Value added (% of GDP) in Cabo Verde and Value added (% of GDP) in China?
Your answer should be very brief. 26.55. In the year 2014, what is the difference between the Value added (% of GDP) of Cabo Verde and Value added (% of GDP) of Nicaragua?
Make the answer very short. 20.89. In the year 2014, what is the difference between the Value added (% of GDP) in China and Value added (% of GDP) in Nicaragua?
Provide a succinct answer. -5.66. What is the ratio of the Value added (% of GDP) in Burkina Faso in 2007 to that in 2008?
Make the answer very short. 1.11. What is the ratio of the Value added (% of GDP) of Cabo Verde in 2007 to that in 2008?
Keep it short and to the point. 1.01. What is the ratio of the Value added (% of GDP) in Nicaragua in 2007 to that in 2008?
Make the answer very short. 1.01. What is the ratio of the Value added (% of GDP) in Burkina Faso in 2007 to that in 2009?
Your answer should be very brief. 1.07. What is the ratio of the Value added (% of GDP) of Cabo Verde in 2007 to that in 2009?
Provide a succinct answer. 1.03. What is the ratio of the Value added (% of GDP) in China in 2007 to that in 2009?
Your response must be concise. 0.97. What is the ratio of the Value added (% of GDP) in Nicaragua in 2007 to that in 2009?
Provide a short and direct response. 1. What is the ratio of the Value added (% of GDP) of Burkina Faso in 2007 to that in 2010?
Offer a terse response. 1.17. What is the ratio of the Value added (% of GDP) of Cabo Verde in 2007 to that in 2010?
Provide a short and direct response. 1.01. What is the ratio of the Value added (% of GDP) in China in 2007 to that in 2010?
Offer a very short reply. 0.97. What is the ratio of the Value added (% of GDP) in Nicaragua in 2007 to that in 2010?
Your answer should be very brief. 1.03. What is the ratio of the Value added (% of GDP) in Burkina Faso in 2007 to that in 2011?
Offer a very short reply. 1.24. What is the ratio of the Value added (% of GDP) in China in 2007 to that in 2011?
Give a very brief answer. 0.97. What is the ratio of the Value added (% of GDP) in Burkina Faso in 2007 to that in 2012?
Your answer should be compact. 1.21. What is the ratio of the Value added (% of GDP) in China in 2007 to that in 2012?
Your answer should be compact. 0.94. What is the ratio of the Value added (% of GDP) in Nicaragua in 2007 to that in 2012?
Provide a short and direct response. 1.1. What is the ratio of the Value added (% of GDP) in Burkina Faso in 2007 to that in 2013?
Make the answer very short. 1.16. What is the ratio of the Value added (% of GDP) in China in 2007 to that in 2013?
Make the answer very short. 0.92. What is the ratio of the Value added (% of GDP) in Nicaragua in 2007 to that in 2013?
Give a very brief answer. 1.07. What is the ratio of the Value added (% of GDP) of Burkina Faso in 2007 to that in 2014?
Keep it short and to the point. 1.13. What is the ratio of the Value added (% of GDP) in Cabo Verde in 2007 to that in 2014?
Offer a terse response. 1. What is the ratio of the Value added (% of GDP) in China in 2007 to that in 2014?
Keep it short and to the point. 0.89. What is the ratio of the Value added (% of GDP) of Nicaragua in 2007 to that in 2014?
Ensure brevity in your answer.  1.09. What is the ratio of the Value added (% of GDP) in Burkina Faso in 2008 to that in 2009?
Provide a succinct answer. 0.97. What is the ratio of the Value added (% of GDP) in Cabo Verde in 2008 to that in 2009?
Your response must be concise. 1.01. What is the ratio of the Value added (% of GDP) of China in 2008 to that in 2009?
Your response must be concise. 0.97. What is the ratio of the Value added (% of GDP) in Nicaragua in 2008 to that in 2009?
Make the answer very short. 0.99. What is the ratio of the Value added (% of GDP) of Burkina Faso in 2008 to that in 2010?
Offer a very short reply. 1.05. What is the ratio of the Value added (% of GDP) in China in 2008 to that in 2010?
Provide a short and direct response. 0.97. What is the ratio of the Value added (% of GDP) of Nicaragua in 2008 to that in 2010?
Give a very brief answer. 1.02. What is the ratio of the Value added (% of GDP) of Burkina Faso in 2008 to that in 2011?
Give a very brief answer. 1.12. What is the ratio of the Value added (% of GDP) of Cabo Verde in 2008 to that in 2011?
Your answer should be compact. 0.99. What is the ratio of the Value added (% of GDP) in China in 2008 to that in 2011?
Offer a very short reply. 0.97. What is the ratio of the Value added (% of GDP) of Nicaragua in 2008 to that in 2011?
Offer a terse response. 1.09. What is the ratio of the Value added (% of GDP) in Burkina Faso in 2008 to that in 2012?
Offer a terse response. 1.09. What is the ratio of the Value added (% of GDP) in Cabo Verde in 2008 to that in 2012?
Offer a very short reply. 0.99. What is the ratio of the Value added (% of GDP) in China in 2008 to that in 2012?
Provide a short and direct response. 0.94. What is the ratio of the Value added (% of GDP) of Nicaragua in 2008 to that in 2012?
Your response must be concise. 1.09. What is the ratio of the Value added (% of GDP) in Burkina Faso in 2008 to that in 2013?
Your response must be concise. 1.04. What is the ratio of the Value added (% of GDP) in Cabo Verde in 2008 to that in 2013?
Your answer should be compact. 0.98. What is the ratio of the Value added (% of GDP) of China in 2008 to that in 2013?
Provide a short and direct response. 0.91. What is the ratio of the Value added (% of GDP) in Nicaragua in 2008 to that in 2013?
Your response must be concise. 1.06. What is the ratio of the Value added (% of GDP) of Burkina Faso in 2008 to that in 2014?
Your response must be concise. 1.02. What is the ratio of the Value added (% of GDP) of Cabo Verde in 2008 to that in 2014?
Provide a succinct answer. 0.98. What is the ratio of the Value added (% of GDP) in China in 2008 to that in 2014?
Keep it short and to the point. 0.89. What is the ratio of the Value added (% of GDP) of Nicaragua in 2008 to that in 2014?
Provide a succinct answer. 1.08. What is the ratio of the Value added (% of GDP) in Burkina Faso in 2009 to that in 2010?
Your answer should be compact. 1.09. What is the ratio of the Value added (% of GDP) of Cabo Verde in 2009 to that in 2010?
Offer a very short reply. 0.98. What is the ratio of the Value added (% of GDP) in China in 2009 to that in 2010?
Provide a short and direct response. 1.01. What is the ratio of the Value added (% of GDP) in Nicaragua in 2009 to that in 2010?
Your answer should be compact. 1.03. What is the ratio of the Value added (% of GDP) in Burkina Faso in 2009 to that in 2011?
Make the answer very short. 1.16. What is the ratio of the Value added (% of GDP) of Cabo Verde in 2009 to that in 2011?
Your answer should be very brief. 0.97. What is the ratio of the Value added (% of GDP) of China in 2009 to that in 2011?
Give a very brief answer. 1. What is the ratio of the Value added (% of GDP) in Nicaragua in 2009 to that in 2011?
Ensure brevity in your answer.  1.1. What is the ratio of the Value added (% of GDP) of Burkina Faso in 2009 to that in 2012?
Your response must be concise. 1.13. What is the ratio of the Value added (% of GDP) in Cabo Verde in 2009 to that in 2012?
Your response must be concise. 0.97. What is the ratio of the Value added (% of GDP) in China in 2009 to that in 2012?
Your answer should be very brief. 0.98. What is the ratio of the Value added (% of GDP) of Nicaragua in 2009 to that in 2012?
Your answer should be very brief. 1.1. What is the ratio of the Value added (% of GDP) in Burkina Faso in 2009 to that in 2013?
Ensure brevity in your answer.  1.08. What is the ratio of the Value added (% of GDP) of Cabo Verde in 2009 to that in 2013?
Provide a short and direct response. 0.97. What is the ratio of the Value added (% of GDP) in China in 2009 to that in 2013?
Give a very brief answer. 0.95. What is the ratio of the Value added (% of GDP) in Nicaragua in 2009 to that in 2013?
Your answer should be very brief. 1.07. What is the ratio of the Value added (% of GDP) in Burkina Faso in 2009 to that in 2014?
Offer a very short reply. 1.06. What is the ratio of the Value added (% of GDP) of China in 2009 to that in 2014?
Provide a succinct answer. 0.92. What is the ratio of the Value added (% of GDP) in Nicaragua in 2009 to that in 2014?
Give a very brief answer. 1.09. What is the ratio of the Value added (% of GDP) of Burkina Faso in 2010 to that in 2011?
Offer a very short reply. 1.06. What is the ratio of the Value added (% of GDP) of Nicaragua in 2010 to that in 2011?
Keep it short and to the point. 1.07. What is the ratio of the Value added (% of GDP) of Burkina Faso in 2010 to that in 2012?
Provide a short and direct response. 1.03. What is the ratio of the Value added (% of GDP) in Cabo Verde in 2010 to that in 2012?
Provide a short and direct response. 0.99. What is the ratio of the Value added (% of GDP) in China in 2010 to that in 2012?
Offer a very short reply. 0.97. What is the ratio of the Value added (% of GDP) of Nicaragua in 2010 to that in 2012?
Ensure brevity in your answer.  1.06. What is the ratio of the Value added (% of GDP) in Burkina Faso in 2010 to that in 2013?
Provide a succinct answer. 0.99. What is the ratio of the Value added (% of GDP) of Cabo Verde in 2010 to that in 2013?
Your answer should be very brief. 0.99. What is the ratio of the Value added (% of GDP) of China in 2010 to that in 2013?
Your answer should be very brief. 0.94. What is the ratio of the Value added (% of GDP) in Nicaragua in 2010 to that in 2013?
Your answer should be compact. 1.04. What is the ratio of the Value added (% of GDP) of Burkina Faso in 2010 to that in 2014?
Offer a very short reply. 0.97. What is the ratio of the Value added (% of GDP) in Cabo Verde in 2010 to that in 2014?
Make the answer very short. 0.99. What is the ratio of the Value added (% of GDP) of China in 2010 to that in 2014?
Your response must be concise. 0.92. What is the ratio of the Value added (% of GDP) in Nicaragua in 2010 to that in 2014?
Your response must be concise. 1.06. What is the ratio of the Value added (% of GDP) in Burkina Faso in 2011 to that in 2012?
Make the answer very short. 0.97. What is the ratio of the Value added (% of GDP) of Cabo Verde in 2011 to that in 2012?
Make the answer very short. 1. What is the ratio of the Value added (% of GDP) in China in 2011 to that in 2012?
Provide a succinct answer. 0.97. What is the ratio of the Value added (% of GDP) of Burkina Faso in 2011 to that in 2013?
Your response must be concise. 0.93. What is the ratio of the Value added (% of GDP) in Cabo Verde in 2011 to that in 2013?
Provide a short and direct response. 0.99. What is the ratio of the Value added (% of GDP) of China in 2011 to that in 2013?
Your answer should be compact. 0.94. What is the ratio of the Value added (% of GDP) of Nicaragua in 2011 to that in 2013?
Offer a very short reply. 0.97. What is the ratio of the Value added (% of GDP) in Burkina Faso in 2011 to that in 2014?
Your answer should be compact. 0.91. What is the ratio of the Value added (% of GDP) of China in 2011 to that in 2014?
Make the answer very short. 0.92. What is the ratio of the Value added (% of GDP) of Nicaragua in 2011 to that in 2014?
Your answer should be very brief. 0.99. What is the ratio of the Value added (% of GDP) in Burkina Faso in 2012 to that in 2013?
Offer a terse response. 0.96. What is the ratio of the Value added (% of GDP) in Cabo Verde in 2012 to that in 2013?
Provide a short and direct response. 0.99. What is the ratio of the Value added (% of GDP) in China in 2012 to that in 2013?
Give a very brief answer. 0.97. What is the ratio of the Value added (% of GDP) of Nicaragua in 2012 to that in 2013?
Provide a short and direct response. 0.97. What is the ratio of the Value added (% of GDP) in Burkina Faso in 2012 to that in 2014?
Ensure brevity in your answer.  0.94. What is the ratio of the Value added (% of GDP) in China in 2012 to that in 2014?
Offer a terse response. 0.95. What is the ratio of the Value added (% of GDP) of Burkina Faso in 2013 to that in 2014?
Your answer should be compact. 0.98. What is the ratio of the Value added (% of GDP) of Cabo Verde in 2013 to that in 2014?
Offer a terse response. 1. What is the ratio of the Value added (% of GDP) of China in 2013 to that in 2014?
Ensure brevity in your answer.  0.98. What is the ratio of the Value added (% of GDP) of Nicaragua in 2013 to that in 2014?
Provide a short and direct response. 1.02. What is the difference between the highest and the second highest Value added (% of GDP) in Burkina Faso?
Offer a very short reply. 3.27. What is the difference between the highest and the second highest Value added (% of GDP) in Cabo Verde?
Provide a succinct answer. 0.29. What is the difference between the highest and the second highest Value added (% of GDP) in China?
Your answer should be very brief. 1.19. What is the difference between the highest and the second highest Value added (% of GDP) of Nicaragua?
Keep it short and to the point. 0.02. What is the difference between the highest and the lowest Value added (% of GDP) in Burkina Faso?
Give a very brief answer. 9.37. What is the difference between the highest and the lowest Value added (% of GDP) of Cabo Verde?
Give a very brief answer. 2.52. What is the difference between the highest and the lowest Value added (% of GDP) in China?
Give a very brief answer. 5.2. What is the difference between the highest and the lowest Value added (% of GDP) in Nicaragua?
Offer a very short reply. 5.37. 